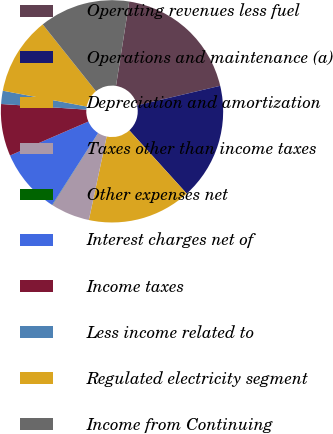Convert chart. <chart><loc_0><loc_0><loc_500><loc_500><pie_chart><fcel>Operating revenues less fuel<fcel>Operations and maintenance (a)<fcel>Depreciation and amortization<fcel>Taxes other than income taxes<fcel>Other expenses net<fcel>Interest charges net of<fcel>Income taxes<fcel>Less income related to<fcel>Regulated electricity segment<fcel>Income from Continuing<nl><fcel>18.84%<fcel>16.96%<fcel>15.08%<fcel>5.68%<fcel>0.04%<fcel>9.44%<fcel>7.56%<fcel>1.92%<fcel>11.32%<fcel>13.2%<nl></chart> 